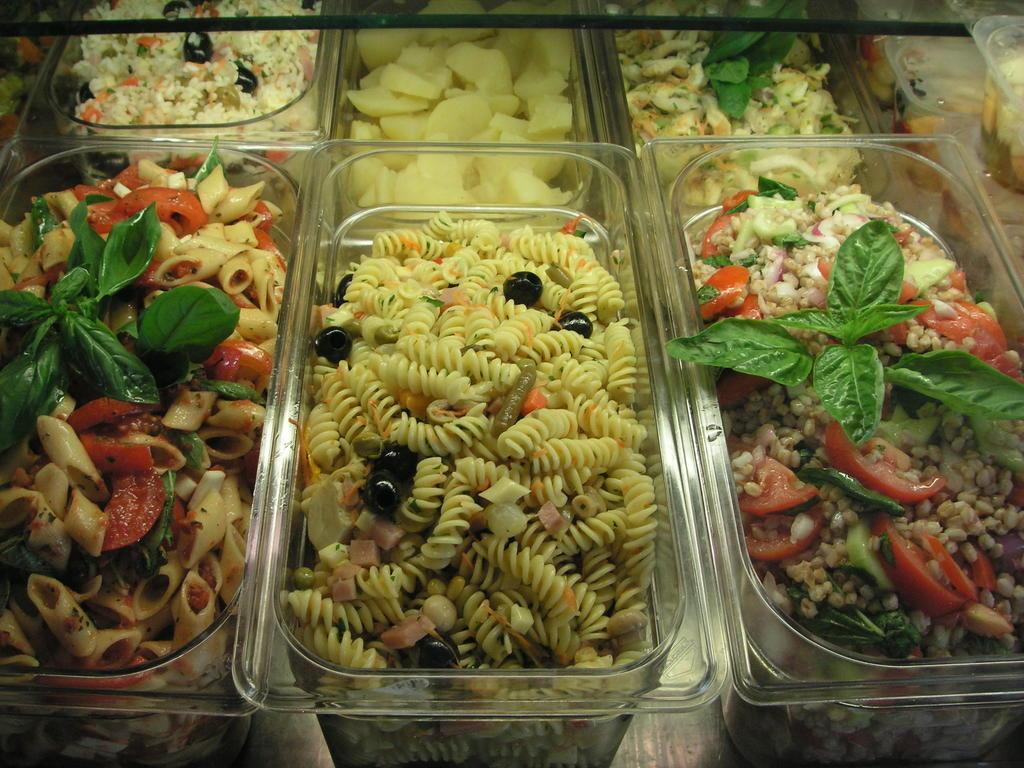Please provide a concise description of this image. In this image I can see the baskets with food. The food is colorful and I can see these baskets are on the surface. 